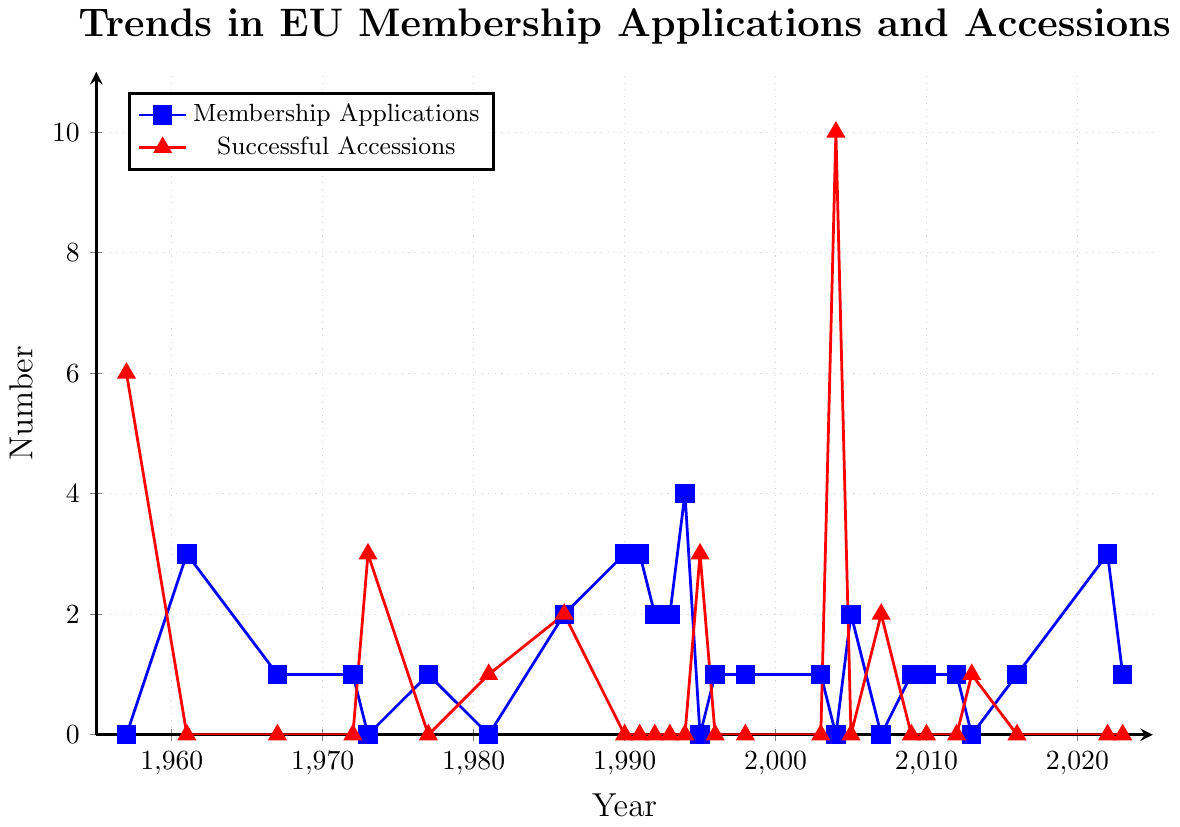What's the total number of successful accessions from 1957 to 2023? To find the total number of successful accessions, we sum all the yearly successful accession counts. This gives us 6 + 0 + 0 + 0 + 3 + 0 + 1 + 2 + 0 + 0 + 0 + 0 + 0 + 3 + 0 + 0 + 0 + 10 + 0 + 2 + 0 + 0 + 0 + 1 + 0 + 0 + 0 = 28
Answer: 28 What year had the highest number of successful accessions? By examining the figure, we observe that the year with the highest number of successful accessions is 2004, with 10 accessions.
Answer: 2004 Which category, membership applications or successful accessions, had more frequency spikes over the entire period? By visually analyzing the lines, we see that there are more frequent spikes in the membership applications line compared to the successful accessions line.
Answer: Membership Applications In which year did both membership applications and successful accessions reach a total of exactly 5? For both categories to sum up to 5, we need to find a year where the sum of the membership applications and successful accessions is 5. By checking the data, we see that in 1986, there are 2 membership applications and 2 successful accessions, meaning the total is 4, not 5. Thus, there is no such year where this condition is satisfied.
Answer: None Compare the trends of membership applications and successful accessions between 1990 and 1995. What's the noticeable difference? During 1990-1995, membership applications show variable numbers (3 in 1990, 3 in 1991, 2 in 1992, 2 in 1993, 4 in 1994, 0 in 1995), indicating continuous interest. However, successful accessions remain at 0 until 1995, when it spikes to 3.
Answer: Membership applications trend upwards, accessions spike in 1995 Which year had equal numbers of membership applications and successful accessions? By cross-referencing the years in the figure, we see that 1986 is the year when both membership applications and successful accessions were equal, both having a value of 2.
Answer: 1986 In which period (decade) did the biggest increase in successful accessions occur? The most significant increase in successful accessions happened in the period from 2000 to 2009, where the number jumped significantly, especially in 2004 with 10 accessions.
Answer: 2000-2009 How many more membership applications were there in 1994 than in 1995? In 1994, there were 4 membership applications, and in 1995, there were 0. Therefore, the difference is 4 - 0 = 4.
Answer: 4 